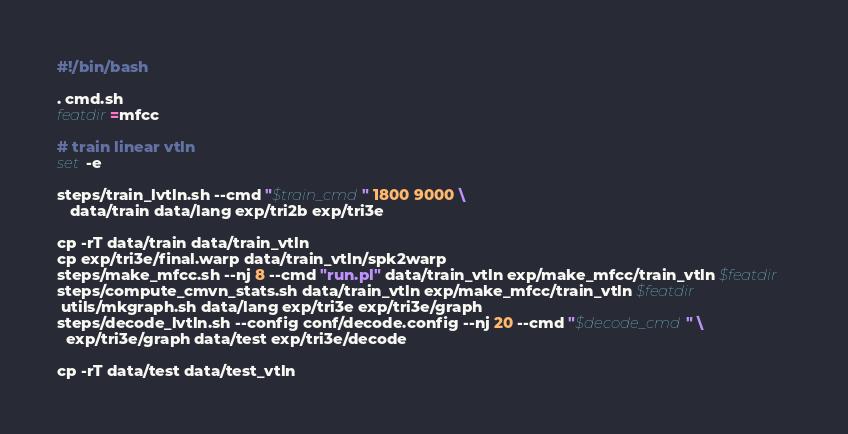<code> <loc_0><loc_0><loc_500><loc_500><_Bash_>#!/bin/bash

. cmd.sh
featdir=mfcc

# train linear vtln
set -e

steps/train_lvtln.sh --cmd "$train_cmd" 1800 9000 \
   data/train data/lang exp/tri2b exp/tri3e

cp -rT data/train data/train_vtln
cp exp/tri3e/final.warp data/train_vtln/spk2warp
steps/make_mfcc.sh --nj 8 --cmd "run.pl" data/train_vtln exp/make_mfcc/train_vtln $featdir  
steps/compute_cmvn_stats.sh data/train_vtln exp/make_mfcc/train_vtln $featdir  
 utils/mkgraph.sh data/lang exp/tri3e exp/tri3e/graph
steps/decode_lvtln.sh --config conf/decode.config --nj 20 --cmd "$decode_cmd" \
  exp/tri3e/graph data/test exp/tri3e/decode

cp -rT data/test data/test_vtln</code> 